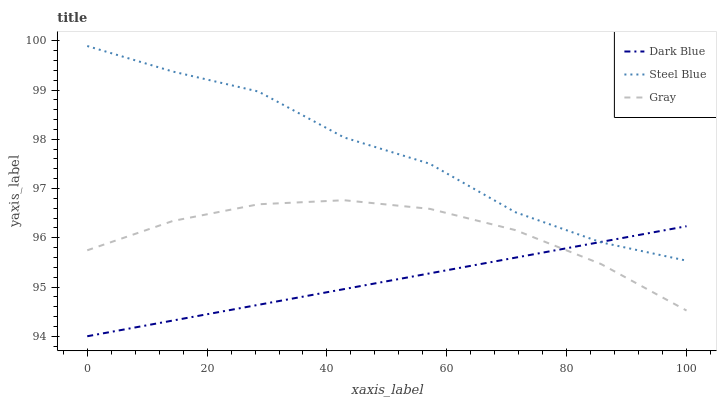Does Dark Blue have the minimum area under the curve?
Answer yes or no. Yes. Does Steel Blue have the maximum area under the curve?
Answer yes or no. Yes. Does Gray have the minimum area under the curve?
Answer yes or no. No. Does Gray have the maximum area under the curve?
Answer yes or no. No. Is Dark Blue the smoothest?
Answer yes or no. Yes. Is Steel Blue the roughest?
Answer yes or no. Yes. Is Gray the smoothest?
Answer yes or no. No. Is Gray the roughest?
Answer yes or no. No. Does Dark Blue have the lowest value?
Answer yes or no. Yes. Does Gray have the lowest value?
Answer yes or no. No. Does Steel Blue have the highest value?
Answer yes or no. Yes. Does Gray have the highest value?
Answer yes or no. No. Is Gray less than Steel Blue?
Answer yes or no. Yes. Is Steel Blue greater than Gray?
Answer yes or no. Yes. Does Gray intersect Dark Blue?
Answer yes or no. Yes. Is Gray less than Dark Blue?
Answer yes or no. No. Is Gray greater than Dark Blue?
Answer yes or no. No. Does Gray intersect Steel Blue?
Answer yes or no. No. 